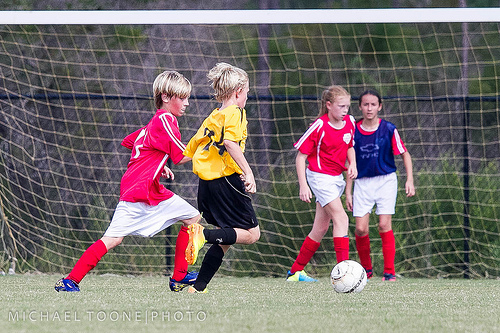<image>
Is there a child in the net? No. The child is not contained within the net. These objects have a different spatial relationship. 